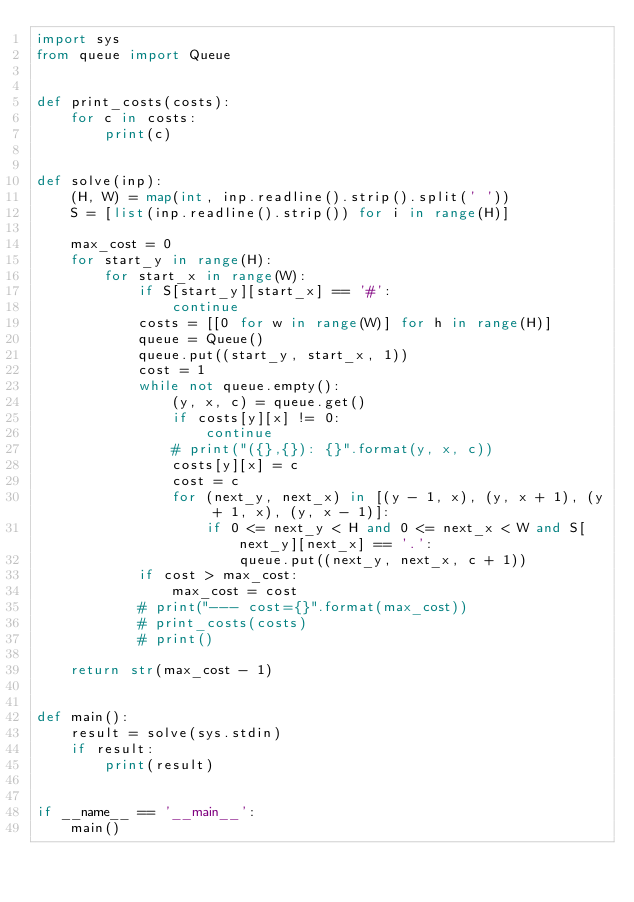<code> <loc_0><loc_0><loc_500><loc_500><_Python_>import sys
from queue import Queue


def print_costs(costs):
    for c in costs:
        print(c)


def solve(inp):
    (H, W) = map(int, inp.readline().strip().split(' '))
    S = [list(inp.readline().strip()) for i in range(H)]

    max_cost = 0
    for start_y in range(H):
        for start_x in range(W):
            if S[start_y][start_x] == '#':
                continue
            costs = [[0 for w in range(W)] for h in range(H)]
            queue = Queue()
            queue.put((start_y, start_x, 1))
            cost = 1
            while not queue.empty():
                (y, x, c) = queue.get()
                if costs[y][x] != 0:
                    continue
                # print("({},{}): {}".format(y, x, c))
                costs[y][x] = c
                cost = c
                for (next_y, next_x) in [(y - 1, x), (y, x + 1), (y + 1, x), (y, x - 1)]:
                    if 0 <= next_y < H and 0 <= next_x < W and S[next_y][next_x] == '.':
                        queue.put((next_y, next_x, c + 1))
            if cost > max_cost:
                max_cost = cost
            # print("--- cost={}".format(max_cost))
            # print_costs(costs)
            # print()

    return str(max_cost - 1)


def main():
    result = solve(sys.stdin)
    if result:
        print(result)


if __name__ == '__main__':
    main()
</code> 